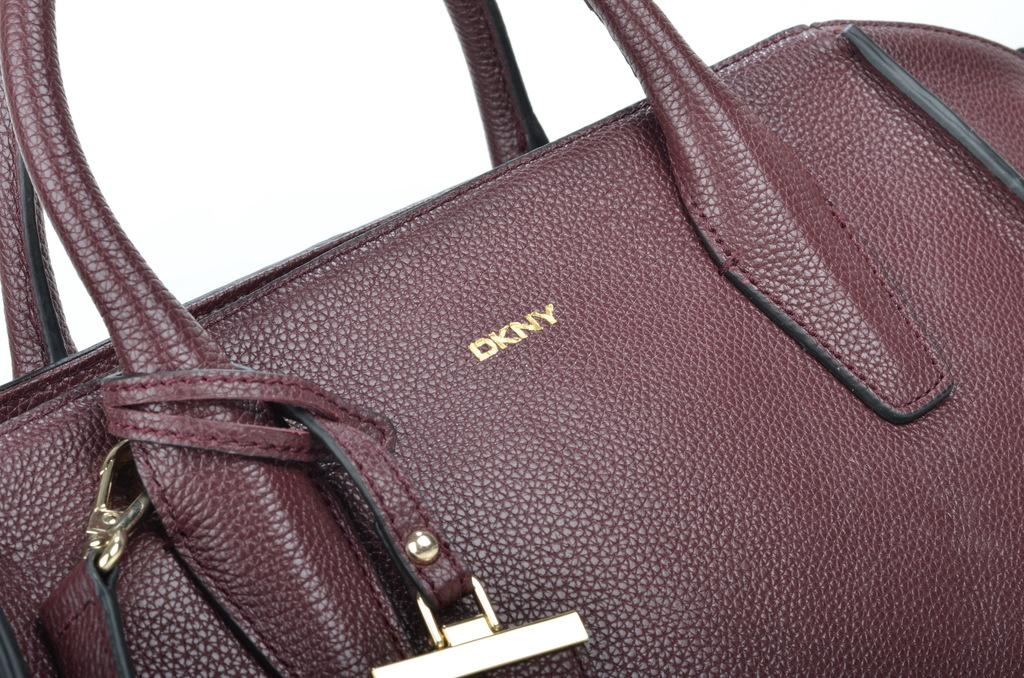What object can be seen in the image? There is a bag in the image. What additional detail can be observed about the bag? The bag has a brand name written on it. How many pigs are visible in the image? There are no pigs present in the image. What impulse might the bag have in the image? The bag is an inanimate object and does not have impulses. 